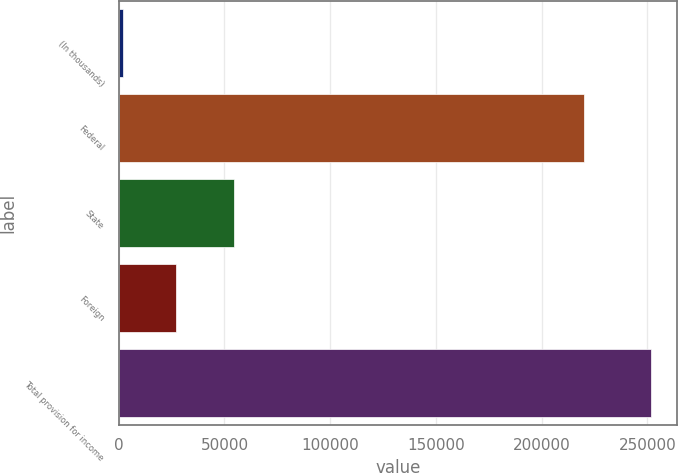<chart> <loc_0><loc_0><loc_500><loc_500><bar_chart><fcel>(In thousands)<fcel>Federal<fcel>State<fcel>Foreign<fcel>Total provision for income<nl><fcel>2007<fcel>220064<fcel>54372<fcel>26967<fcel>251607<nl></chart> 